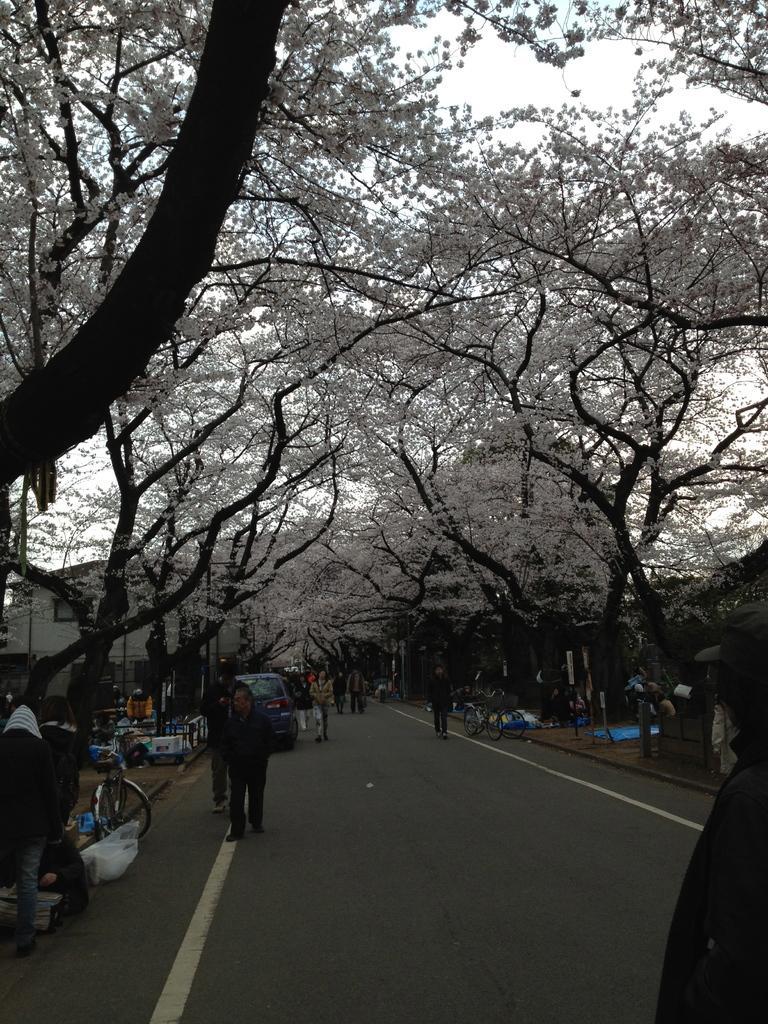Please provide a concise description of this image. In this picture there is a view of the road lane. In the front there are some men and women walking on road. On both the side there are some white color flower trees. 